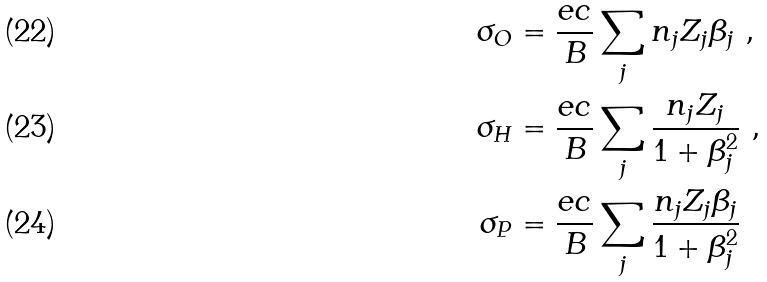Convert formula to latex. <formula><loc_0><loc_0><loc_500><loc_500>\sigma _ { O } & = \frac { e c } { B } \sum _ { j } n _ { j } Z _ { j } \beta _ { j } \ , \\ \sigma _ { H } & = \frac { e c } { B } \sum _ { j } \frac { n _ { j } Z _ { j } } { 1 + \beta _ { j } ^ { 2 } } \ , \\ \sigma _ { P } & = \frac { e c } { B } \sum _ { j } \frac { n _ { j } Z _ { j } \beta _ { j } } { 1 + \beta _ { j } ^ { 2 } }</formula> 